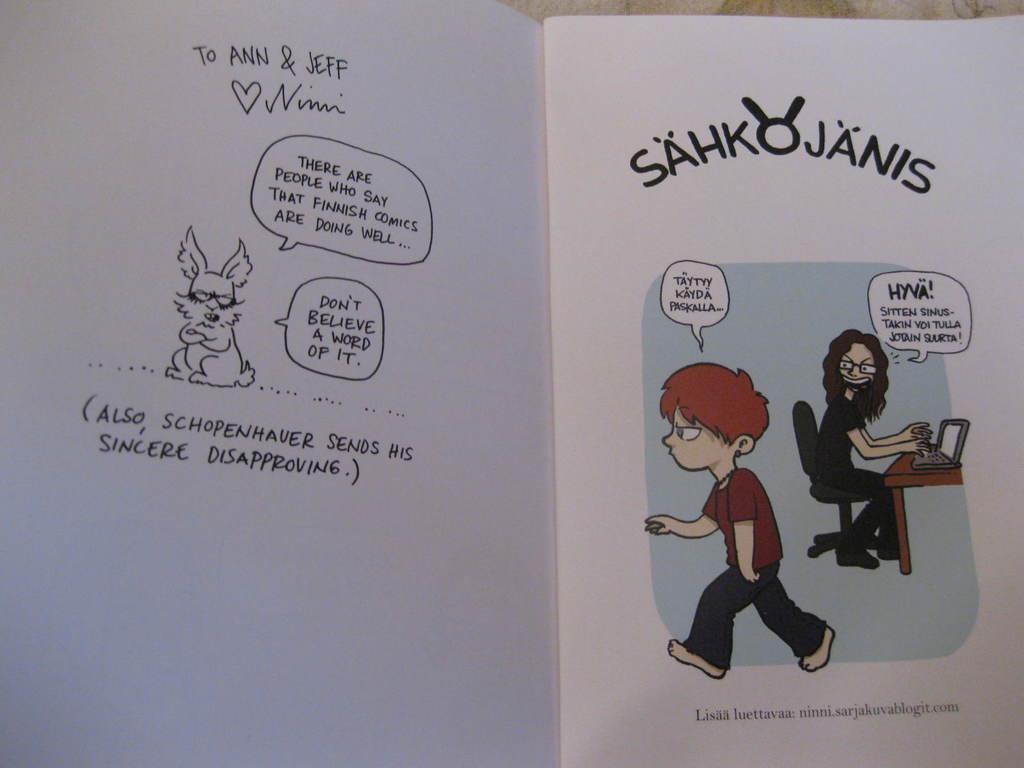Please provide a concise description of this image. In this image there is a book on the floor. In the book one person is walking and another person is sitting on the chair. In front of him there is a table. On top of the table there is a laptop. 